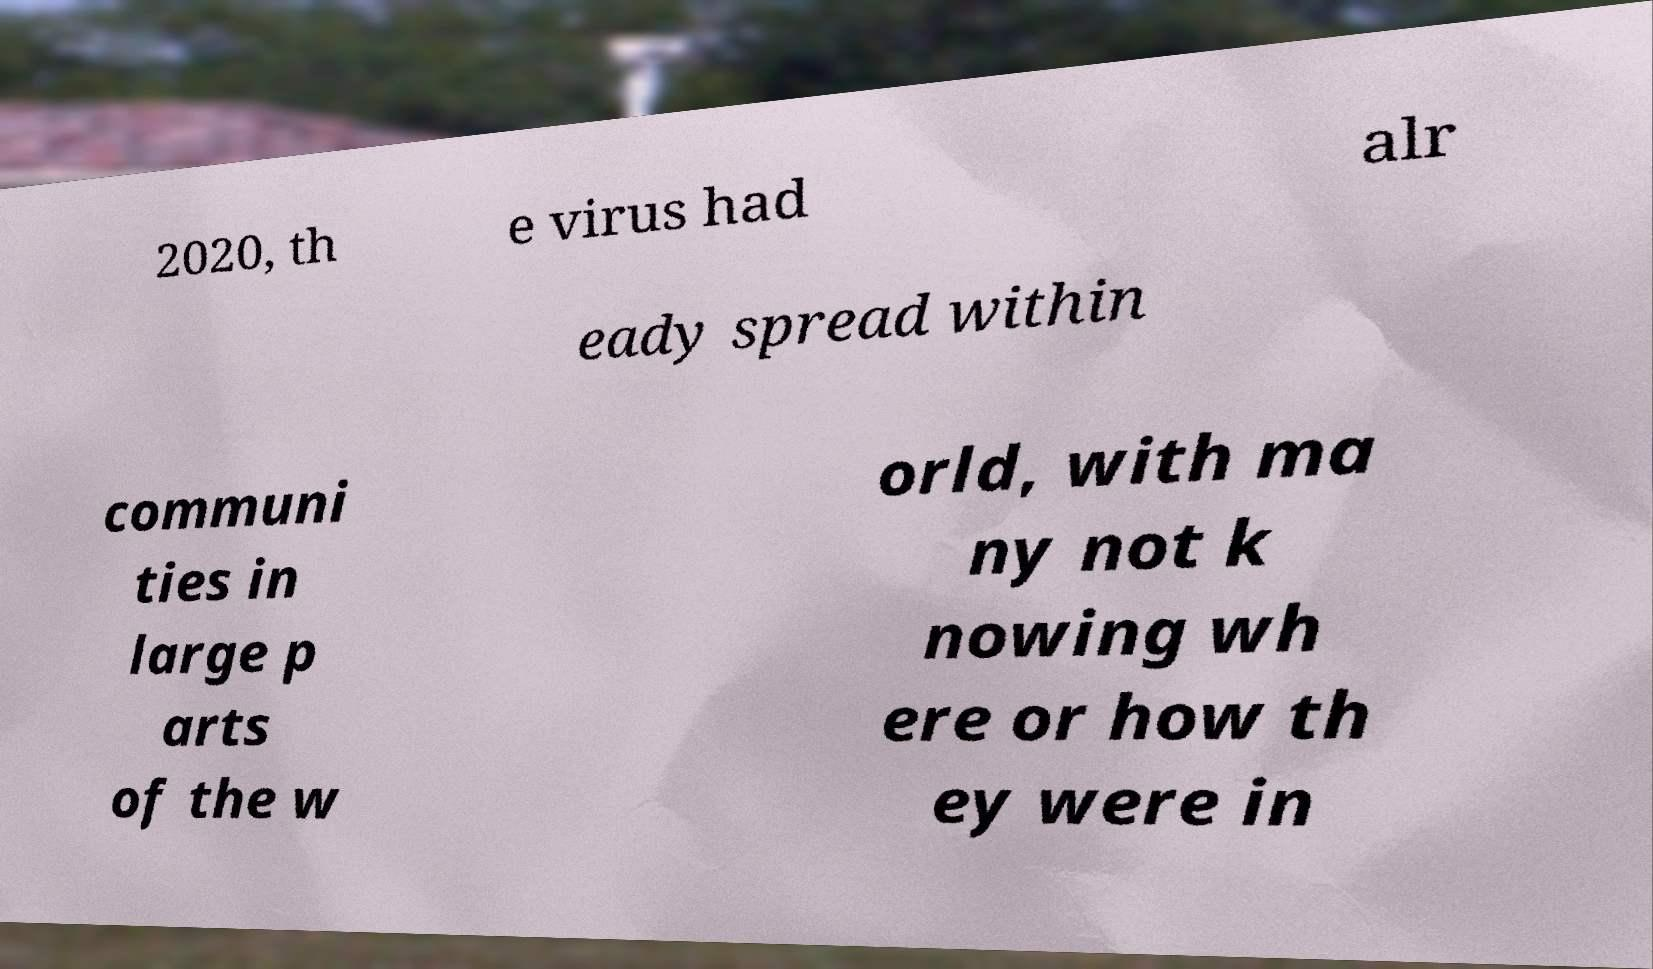What messages or text are displayed in this image? I need them in a readable, typed format. 2020, th e virus had alr eady spread within communi ties in large p arts of the w orld, with ma ny not k nowing wh ere or how th ey were in 